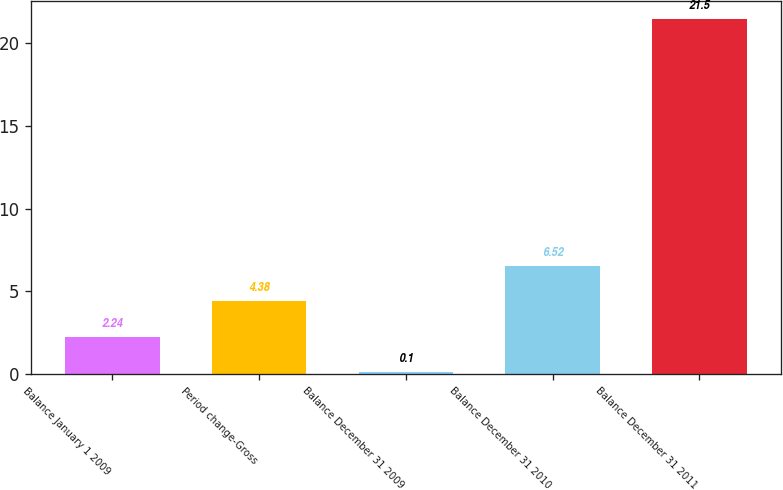<chart> <loc_0><loc_0><loc_500><loc_500><bar_chart><fcel>Balance January 1 2009<fcel>Period change-Gross<fcel>Balance December 31 2009<fcel>Balance December 31 2010<fcel>Balance December 31 2011<nl><fcel>2.24<fcel>4.38<fcel>0.1<fcel>6.52<fcel>21.5<nl></chart> 